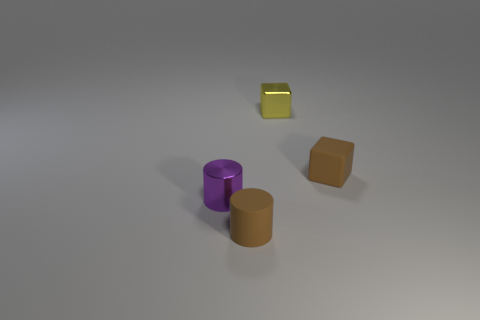Are there any tiny purple objects on the right side of the tiny cylinder on the right side of the metallic object that is in front of the brown cube?
Provide a succinct answer. No. What material is the purple thing in front of the small metal block?
Offer a terse response. Metal. There is a tiny thing that is in front of the small yellow metal block and on the right side of the tiny matte cylinder; what color is it?
Your answer should be very brief. Brown. What shape is the purple thing that is the same material as the tiny yellow object?
Your response must be concise. Cylinder. How many things are on the left side of the small shiny cube and on the right side of the tiny purple metallic object?
Keep it short and to the point. 1. There is a yellow object; are there any tiny matte things on the right side of it?
Offer a very short reply. Yes. Do the matte thing that is on the right side of the small matte cylinder and the metallic object behind the metal cylinder have the same shape?
Your answer should be compact. Yes. How many objects are brown matte objects or brown rubber things to the left of the yellow thing?
Provide a short and direct response. 2. Do the brown object in front of the small purple cylinder and the tiny brown block have the same material?
Give a very brief answer. Yes. What number of objects are either small brown rubber cylinders or large green metallic balls?
Your response must be concise. 1. 